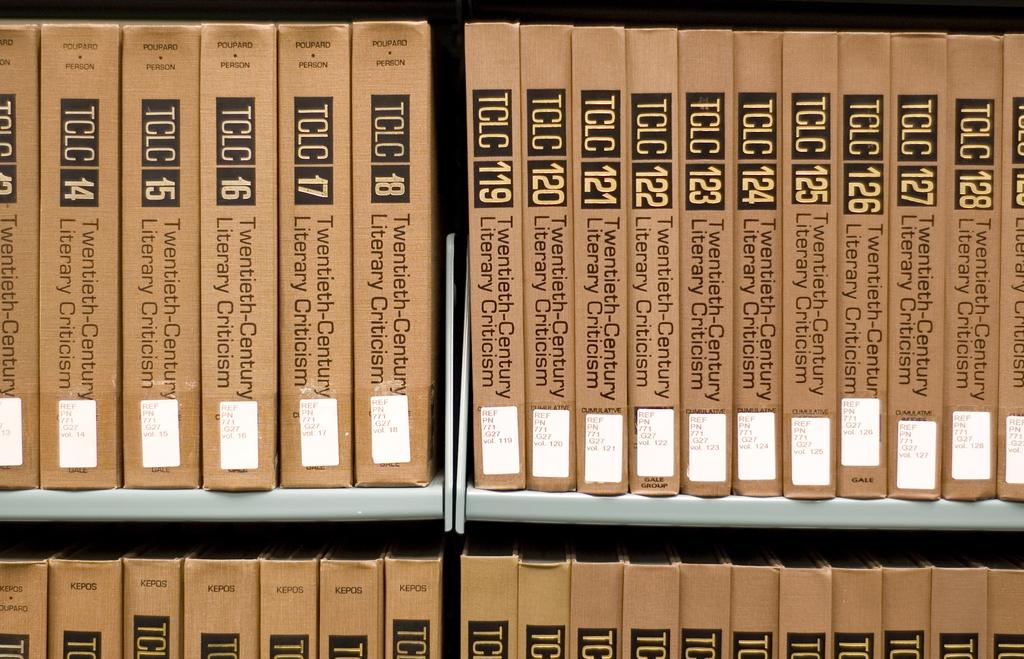<image>
Offer a succinct explanation of the picture presented. Rows of brown TCLC books including their numbers. 